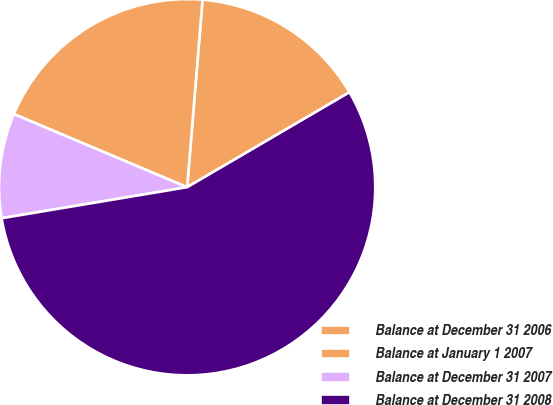Convert chart to OTSL. <chart><loc_0><loc_0><loc_500><loc_500><pie_chart><fcel>Balance at December 31 2006<fcel>Balance at January 1 2007<fcel>Balance at December 31 2007<fcel>Balance at December 31 2008<nl><fcel>15.27%<fcel>19.95%<fcel>8.99%<fcel>55.78%<nl></chart> 